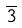<formula> <loc_0><loc_0><loc_500><loc_500>\overline { 3 }</formula> 